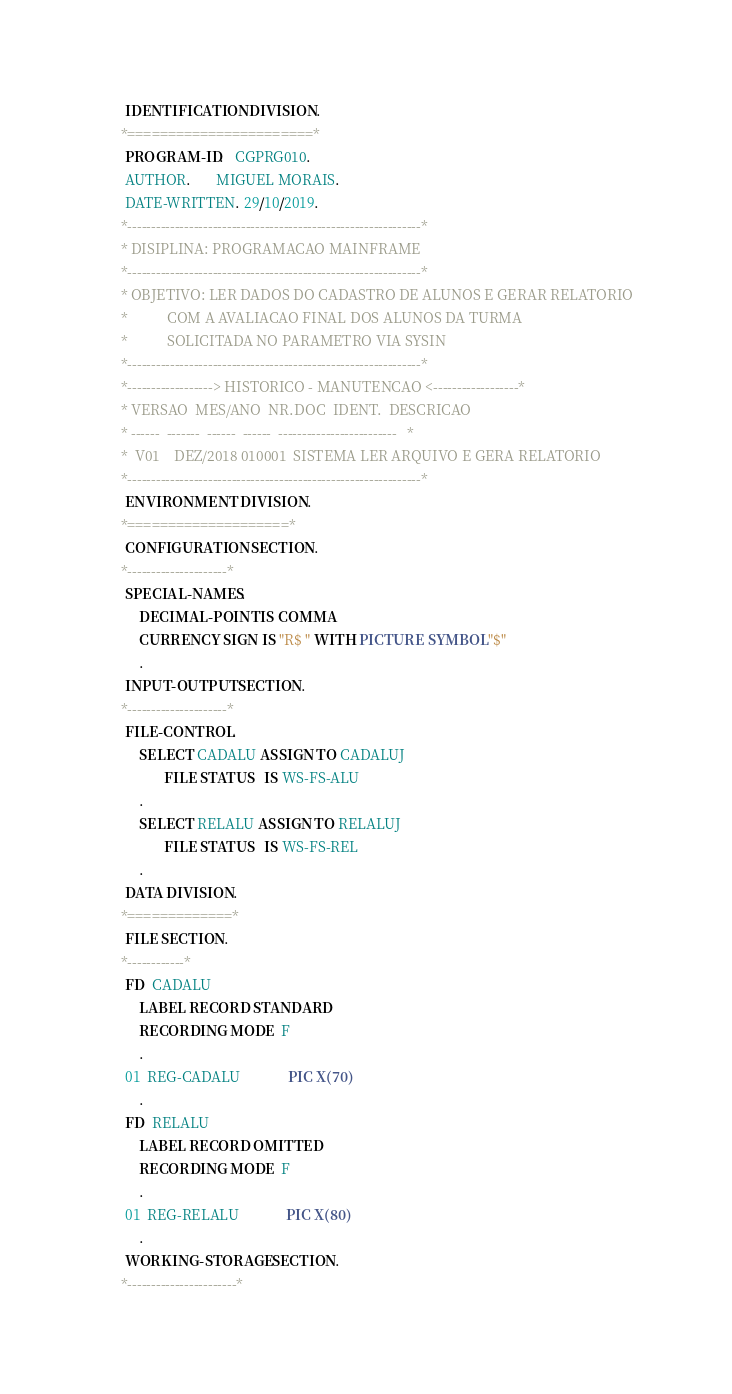Convert code to text. <code><loc_0><loc_0><loc_500><loc_500><_COBOL_>       IDENTIFICATION DIVISION.
      *=======================*
       PROGRAM-ID.   CGPRG010.
       AUTHOR.       MIGUEL MORAIS.
       DATE-WRITTEN. 29/10/2019.
      *--------------------------------------------------------------*
      * DISIPLINA: PROGRAMACAO MAINFRAME
      *--------------------------------------------------------------*
      * OBJETIVO: LER DADOS DO CADASTRO DE ALUNOS E GERAR RELATORIO
      *           COM A AVALIACAO FINAL DOS ALUNOS DA TURMA
      *           SOLICITADA NO PARAMETRO VIA SYSIN
      *--------------------------------------------------------------*
      *------------------> HISTORICO - MANUTENCAO <------------------*
      * VERSAO  MES/ANO  NR.DOC  IDENT.  DESCRICAO
      * ------  -------  ------  ------  -------------------------   *
      *  V01    DEZ/2018 010001  SISTEMA LER ARQUIVO E GERA RELATORIO
      *--------------------------------------------------------------*
       ENVIRONMENT DIVISION.
      *====================*
       CONFIGURATION SECTION.
      *---------------------*
       SPECIAL-NAMES.
           DECIMAL-POINT IS COMMA
           CURRENCY SIGN IS "R$ " WITH PICTURE SYMBOL "$"
           .
       INPUT-OUTPUT SECTION.
      *---------------------*
       FILE-CONTROL.
           SELECT CADALU ASSIGN TO CADALUJ
                  FILE STATUS   IS WS-FS-ALU
           .
           SELECT RELALU ASSIGN TO RELALUJ
                  FILE STATUS   IS WS-FS-REL
           .
       DATA DIVISION.
      *=============*
       FILE SECTION.
      *------------*
       FD  CADALU
           LABEL RECORD STANDARD
           RECORDING MODE  F
           .
       01  REG-CADALU             PIC X(70)
           .
       FD  RELALU
           LABEL RECORD OMITTED
           RECORDING MODE  F
           .
       01  REG-RELALU             PIC X(80)
           .
       WORKING-STORAGE SECTION.
      *-----------------------*</code> 